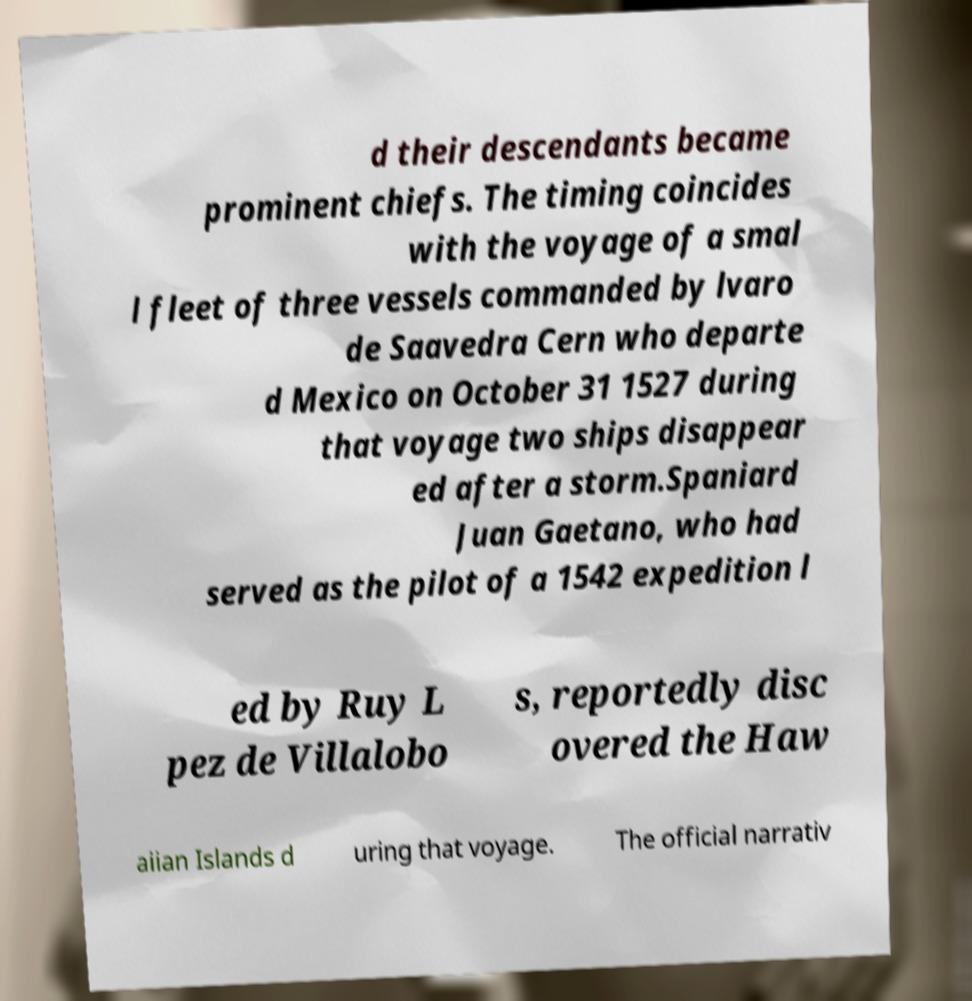I need the written content from this picture converted into text. Can you do that? d their descendants became prominent chiefs. The timing coincides with the voyage of a smal l fleet of three vessels commanded by lvaro de Saavedra Cern who departe d Mexico on October 31 1527 during that voyage two ships disappear ed after a storm.Spaniard Juan Gaetano, who had served as the pilot of a 1542 expedition l ed by Ruy L pez de Villalobo s, reportedly disc overed the Haw aiian Islands d uring that voyage. The official narrativ 